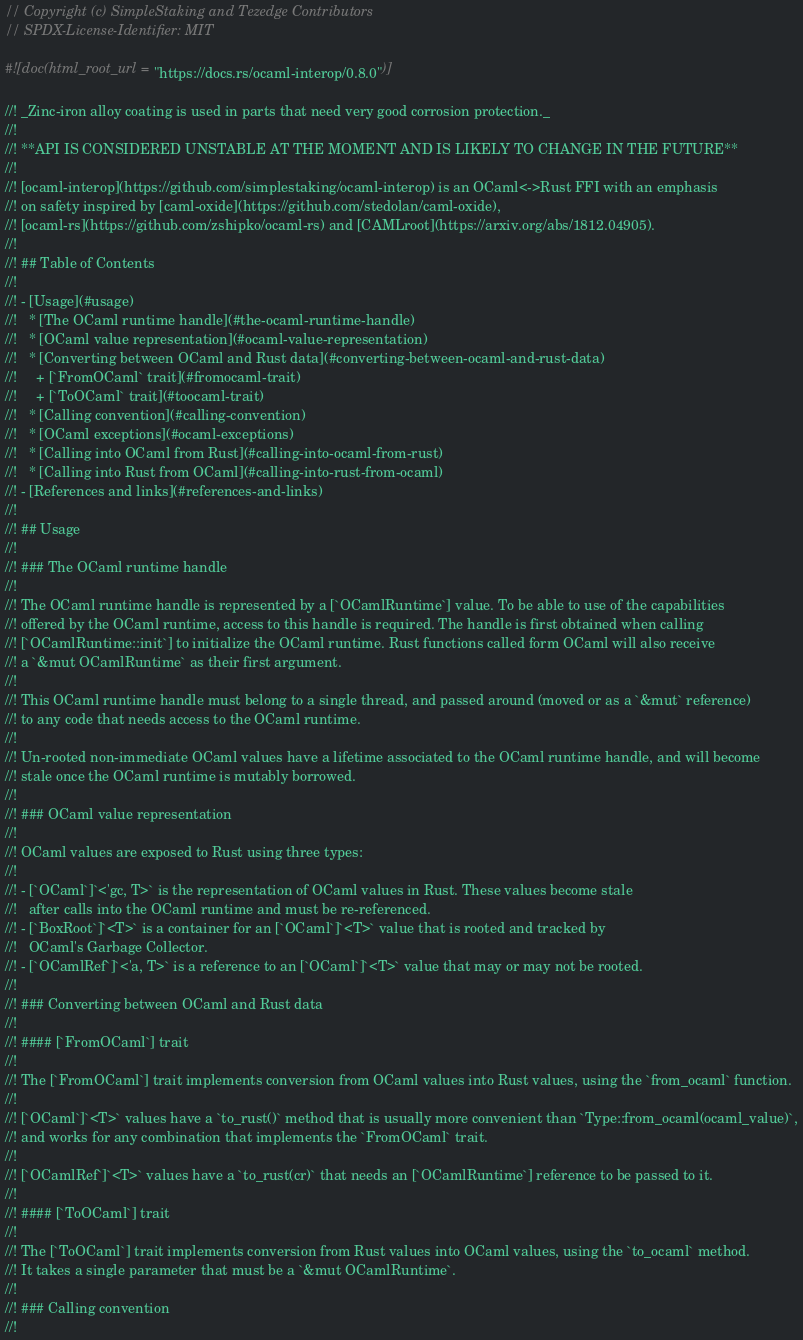Convert code to text. <code><loc_0><loc_0><loc_500><loc_500><_Rust_>// Copyright (c) SimpleStaking and Tezedge Contributors
// SPDX-License-Identifier: MIT

#![doc(html_root_url = "https://docs.rs/ocaml-interop/0.8.0")]

//! _Zinc-iron alloy coating is used in parts that need very good corrosion protection._
//!
//! **API IS CONSIDERED UNSTABLE AT THE MOMENT AND IS LIKELY TO CHANGE IN THE FUTURE**
//!
//! [ocaml-interop](https://github.com/simplestaking/ocaml-interop) is an OCaml<->Rust FFI with an emphasis
//! on safety inspired by [caml-oxide](https://github.com/stedolan/caml-oxide),
//! [ocaml-rs](https://github.com/zshipko/ocaml-rs) and [CAMLroot](https://arxiv.org/abs/1812.04905).
//!
//! ## Table of Contents
//!
//! - [Usage](#usage)
//!   * [The OCaml runtime handle](#the-ocaml-runtime-handle)
//!   * [OCaml value representation](#ocaml-value-representation)
//!   * [Converting between OCaml and Rust data](#converting-between-ocaml-and-rust-data)
//!     + [`FromOCaml` trait](#fromocaml-trait)
//!     + [`ToOCaml` trait](#toocaml-trait)
//!   * [Calling convention](#calling-convention)
//!   * [OCaml exceptions](#ocaml-exceptions)
//!   * [Calling into OCaml from Rust](#calling-into-ocaml-from-rust)
//!   * [Calling into Rust from OCaml](#calling-into-rust-from-ocaml)
//! - [References and links](#references-and-links)
//!
//! ## Usage
//!
//! ### The OCaml runtime handle
//!
//! The OCaml runtime handle is represented by a [`OCamlRuntime`] value. To be able to use of the capabilities
//! offered by the OCaml runtime, access to this handle is required. The handle is first obtained when calling
//! [`OCamlRuntime::init`] to initialize the OCaml runtime. Rust functions called form OCaml will also receive
//! a `&mut OCamlRuntime` as their first argument.
//!
//! This OCaml runtime handle must belong to a single thread, and passed around (moved or as a `&mut` reference)
//! to any code that needs access to the OCaml runtime.
//!
//! Un-rooted non-immediate OCaml values have a lifetime associated to the OCaml runtime handle, and will become
//! stale once the OCaml runtime is mutably borrowed.
//!
//! ### OCaml value representation
//!
//! OCaml values are exposed to Rust using three types:
//!
//! - [`OCaml`]`<'gc, T>` is the representation of OCaml values in Rust. These values become stale
//!   after calls into the OCaml runtime and must be re-referenced.
//! - [`BoxRoot`]`<T>` is a container for an [`OCaml`]`<T>` value that is rooted and tracked by
//!   OCaml's Garbage Collector.
//! - [`OCamlRef`]`<'a, T>` is a reference to an [`OCaml`]`<T>` value that may or may not be rooted.
//!
//! ### Converting between OCaml and Rust data
//!
//! #### [`FromOCaml`] trait
//!
//! The [`FromOCaml`] trait implements conversion from OCaml values into Rust values, using the `from_ocaml` function.
//!
//! [`OCaml`]`<T>` values have a `to_rust()` method that is usually more convenient than `Type::from_ocaml(ocaml_value)`,
//! and works for any combination that implements the `FromOCaml` trait.
//!
//! [`OCamlRef`]`<T>` values have a `to_rust(cr)` that needs an [`OCamlRuntime`] reference to be passed to it.
//!
//! #### [`ToOCaml`] trait
//!
//! The [`ToOCaml`] trait implements conversion from Rust values into OCaml values, using the `to_ocaml` method.
//! It takes a single parameter that must be a `&mut OCamlRuntime`.
//!
//! ### Calling convention
//!</code> 